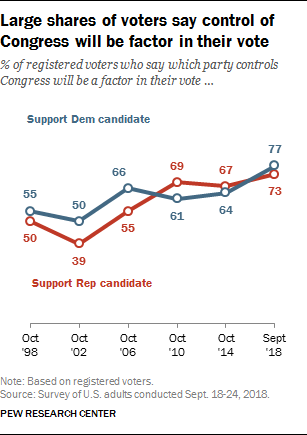Outline some significant characteristics in this image. The total value of Support Dem candidates and Support Rep candidates in October 2014 was 131. The Support Rep candidate is depicted in the chart as being colored red. 